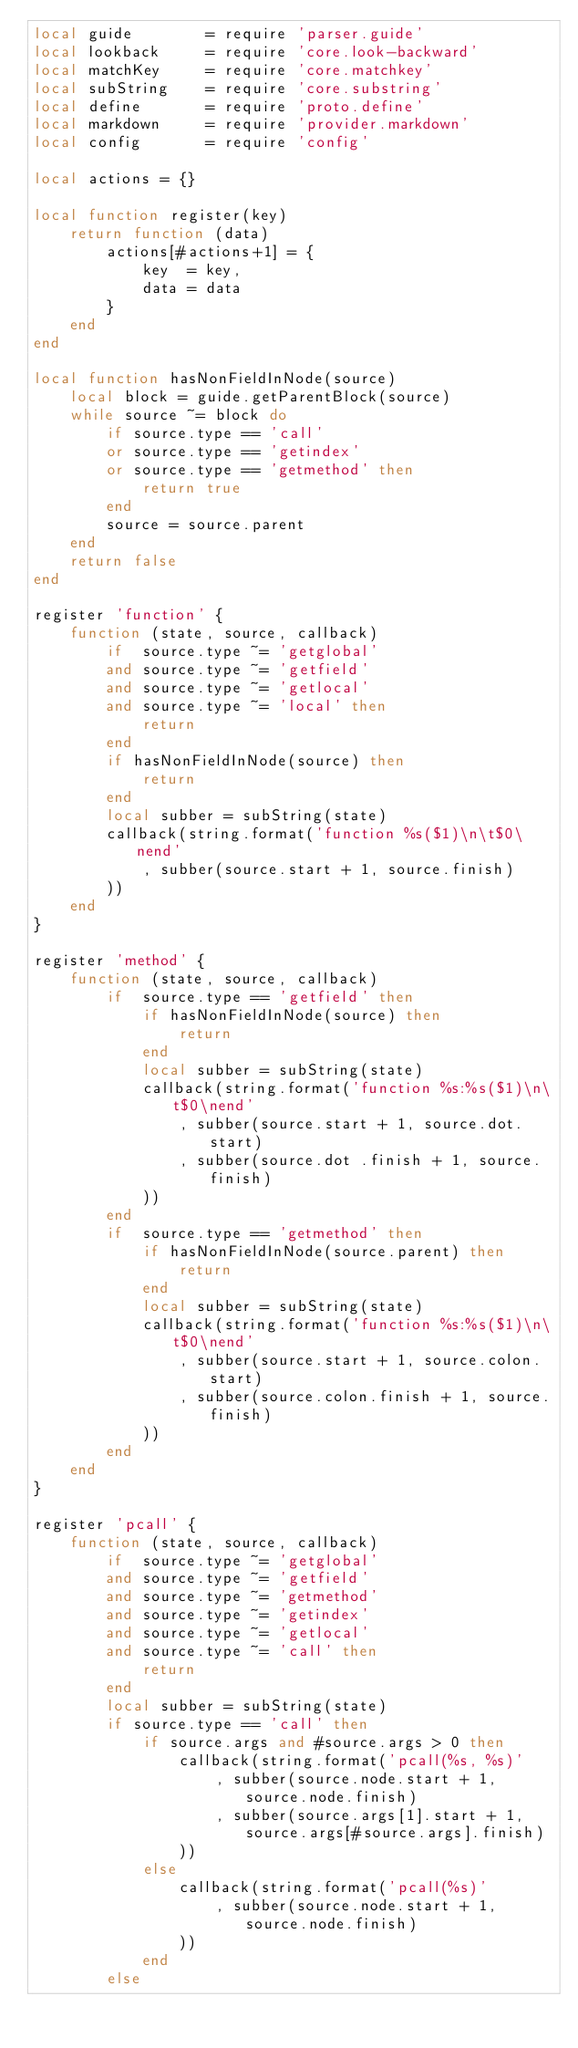<code> <loc_0><loc_0><loc_500><loc_500><_Lua_>local guide        = require 'parser.guide'
local lookback     = require 'core.look-backward'
local matchKey     = require 'core.matchkey'
local subString    = require 'core.substring'
local define       = require 'proto.define'
local markdown     = require 'provider.markdown'
local config       = require 'config'

local actions = {}

local function register(key)
    return function (data)
        actions[#actions+1] = {
            key  = key,
            data = data
        }
    end
end

local function hasNonFieldInNode(source)
    local block = guide.getParentBlock(source)
    while source ~= block do
        if source.type == 'call'
        or source.type == 'getindex'
        or source.type == 'getmethod' then
            return true
        end
        source = source.parent
    end
    return false
end

register 'function' {
    function (state, source, callback)
        if  source.type ~= 'getglobal'
        and source.type ~= 'getfield'
        and source.type ~= 'getlocal'
        and source.type ~= 'local' then
            return
        end
        if hasNonFieldInNode(source) then
            return
        end
        local subber = subString(state)
        callback(string.format('function %s($1)\n\t$0\nend'
            , subber(source.start + 1, source.finish)
        ))
    end
}

register 'method' {
    function (state, source, callback)
        if  source.type == 'getfield' then
            if hasNonFieldInNode(source) then
                return
            end
            local subber = subString(state)
            callback(string.format('function %s:%s($1)\n\t$0\nend'
                , subber(source.start + 1, source.dot.start)
                , subber(source.dot .finish + 1, source.finish)
            ))
        end
        if  source.type == 'getmethod' then
            if hasNonFieldInNode(source.parent) then
                return
            end
            local subber = subString(state)
            callback(string.format('function %s:%s($1)\n\t$0\nend'
                , subber(source.start + 1, source.colon.start)
                , subber(source.colon.finish + 1, source.finish)
            ))
        end
    end
}

register 'pcall' {
    function (state, source, callback)
        if  source.type ~= 'getglobal'
        and source.type ~= 'getfield'
        and source.type ~= 'getmethod'
        and source.type ~= 'getindex'
        and source.type ~= 'getlocal'
        and source.type ~= 'call' then
            return
        end
        local subber = subString(state)
        if source.type == 'call' then
            if source.args and #source.args > 0 then
                callback(string.format('pcall(%s, %s)'
                    , subber(source.node.start + 1, source.node.finish)
                    , subber(source.args[1].start + 1, source.args[#source.args].finish)
                ))
            else
                callback(string.format('pcall(%s)'
                    , subber(source.node.start + 1, source.node.finish)
                ))
            end
        else</code> 